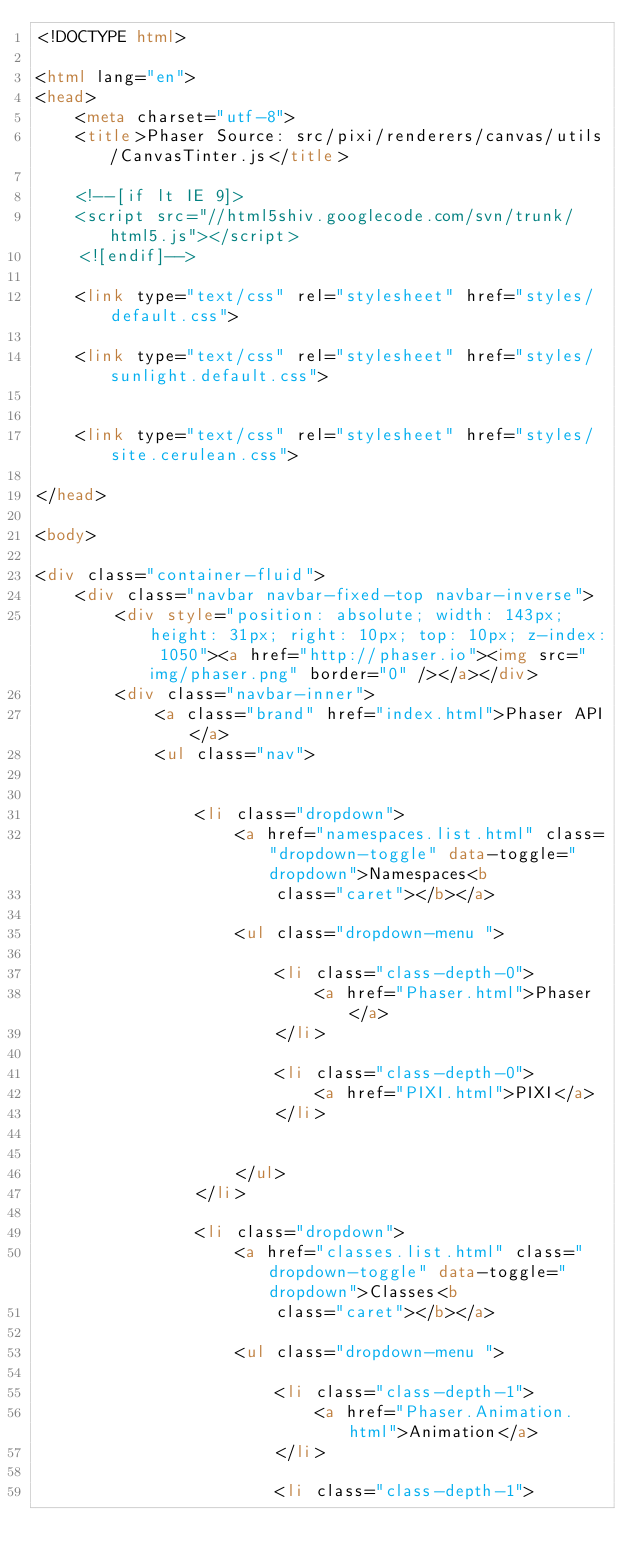Convert code to text. <code><loc_0><loc_0><loc_500><loc_500><_HTML_><!DOCTYPE html>

<html lang="en">
<head>
	<meta charset="utf-8">
	<title>Phaser Source: src/pixi/renderers/canvas/utils/CanvasTinter.js</title>

	<!--[if lt IE 9]>
	<script src="//html5shiv.googlecode.com/svn/trunk/html5.js"></script>
	<![endif]-->

	<link type="text/css" rel="stylesheet" href="styles/default.css">

	<link type="text/css" rel="stylesheet" href="styles/sunlight.default.css">

	
	<link type="text/css" rel="stylesheet" href="styles/site.cerulean.css">
	
</head>

<body>

<div class="container-fluid">
	<div class="navbar navbar-fixed-top navbar-inverse">
		<div style="position: absolute; width: 143px; height: 31px; right: 10px; top: 10px; z-index: 1050"><a href="http://phaser.io"><img src="img/phaser.png" border="0" /></a></div>
		<div class="navbar-inner">
			<a class="brand" href="index.html">Phaser API</a>
			<ul class="nav">

				
				<li class="dropdown">
					<a href="namespaces.list.html" class="dropdown-toggle" data-toggle="dropdown">Namespaces<b
						class="caret"></b></a>

					<ul class="dropdown-menu ">
						
						<li class="class-depth-0">
							<a href="Phaser.html">Phaser</a>
						</li>
						
						<li class="class-depth-0">
							<a href="PIXI.html">PIXI</a>
						</li>
						

					</ul>
				</li>
				
				<li class="dropdown">
					<a href="classes.list.html" class="dropdown-toggle" data-toggle="dropdown">Classes<b
						class="caret"></b></a>

					<ul class="dropdown-menu ">
						
						<li class="class-depth-1">
							<a href="Phaser.Animation.html">Animation</a>
						</li>
						
						<li class="class-depth-1"></code> 